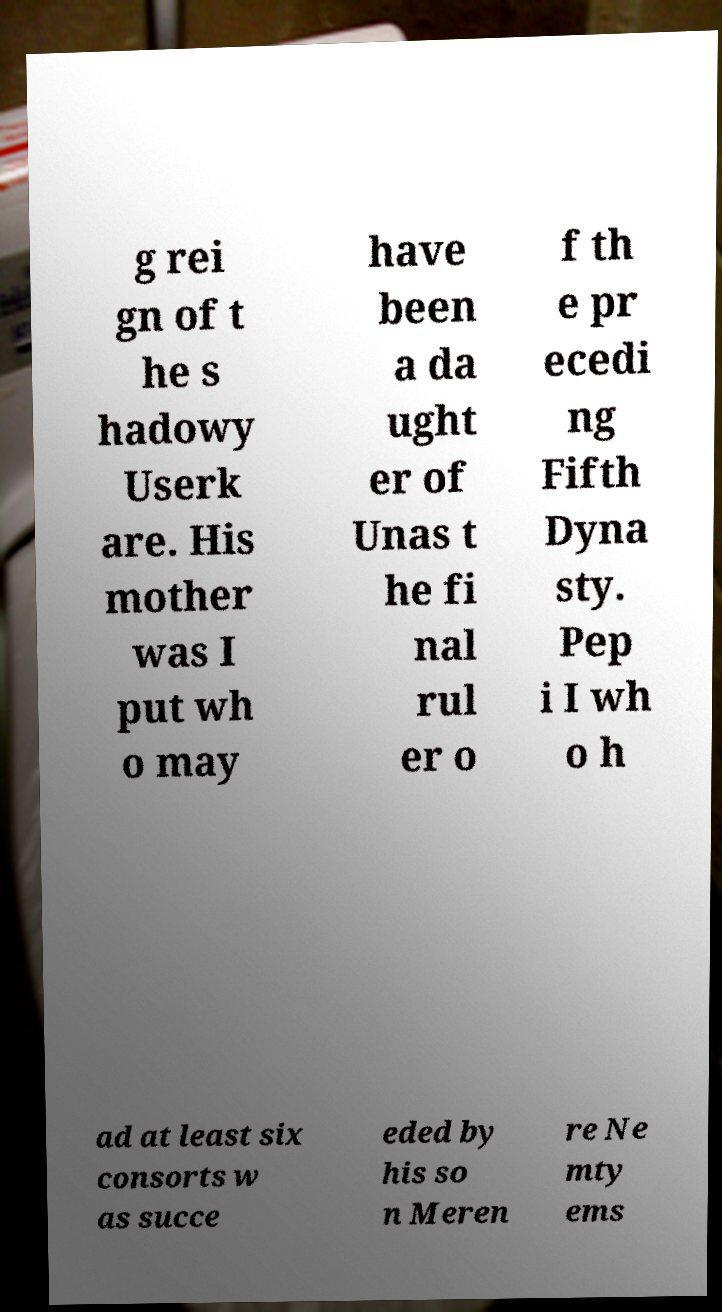Could you extract and type out the text from this image? g rei gn of t he s hadowy Userk are. His mother was I put wh o may have been a da ught er of Unas t he fi nal rul er o f th e pr ecedi ng Fifth Dyna sty. Pep i I wh o h ad at least six consorts w as succe eded by his so n Meren re Ne mty ems 